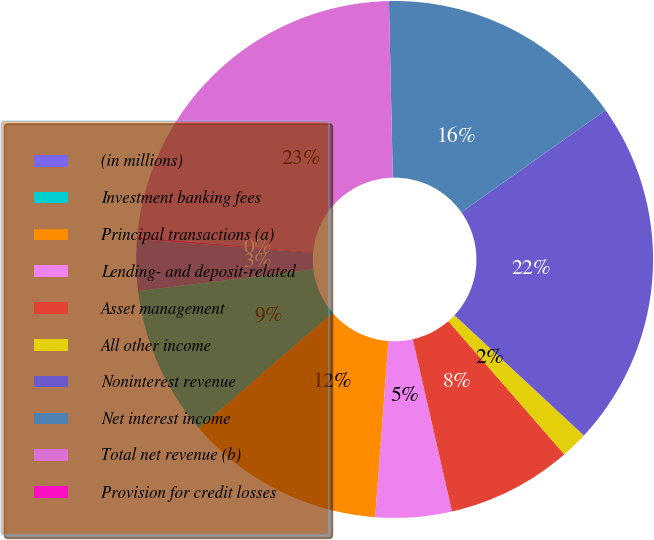Convert chart to OTSL. <chart><loc_0><loc_0><loc_500><loc_500><pie_chart><fcel>(in millions)<fcel>Investment banking fees<fcel>Principal transactions (a)<fcel>Lending- and deposit-related<fcel>Asset management<fcel>All other income<fcel>Noninterest revenue<fcel>Net interest income<fcel>Total net revenue (b)<fcel>Provision for credit losses<nl><fcel>3.21%<fcel>9.38%<fcel>12.47%<fcel>4.76%<fcel>7.84%<fcel>1.67%<fcel>21.72%<fcel>15.55%<fcel>23.26%<fcel>0.13%<nl></chart> 